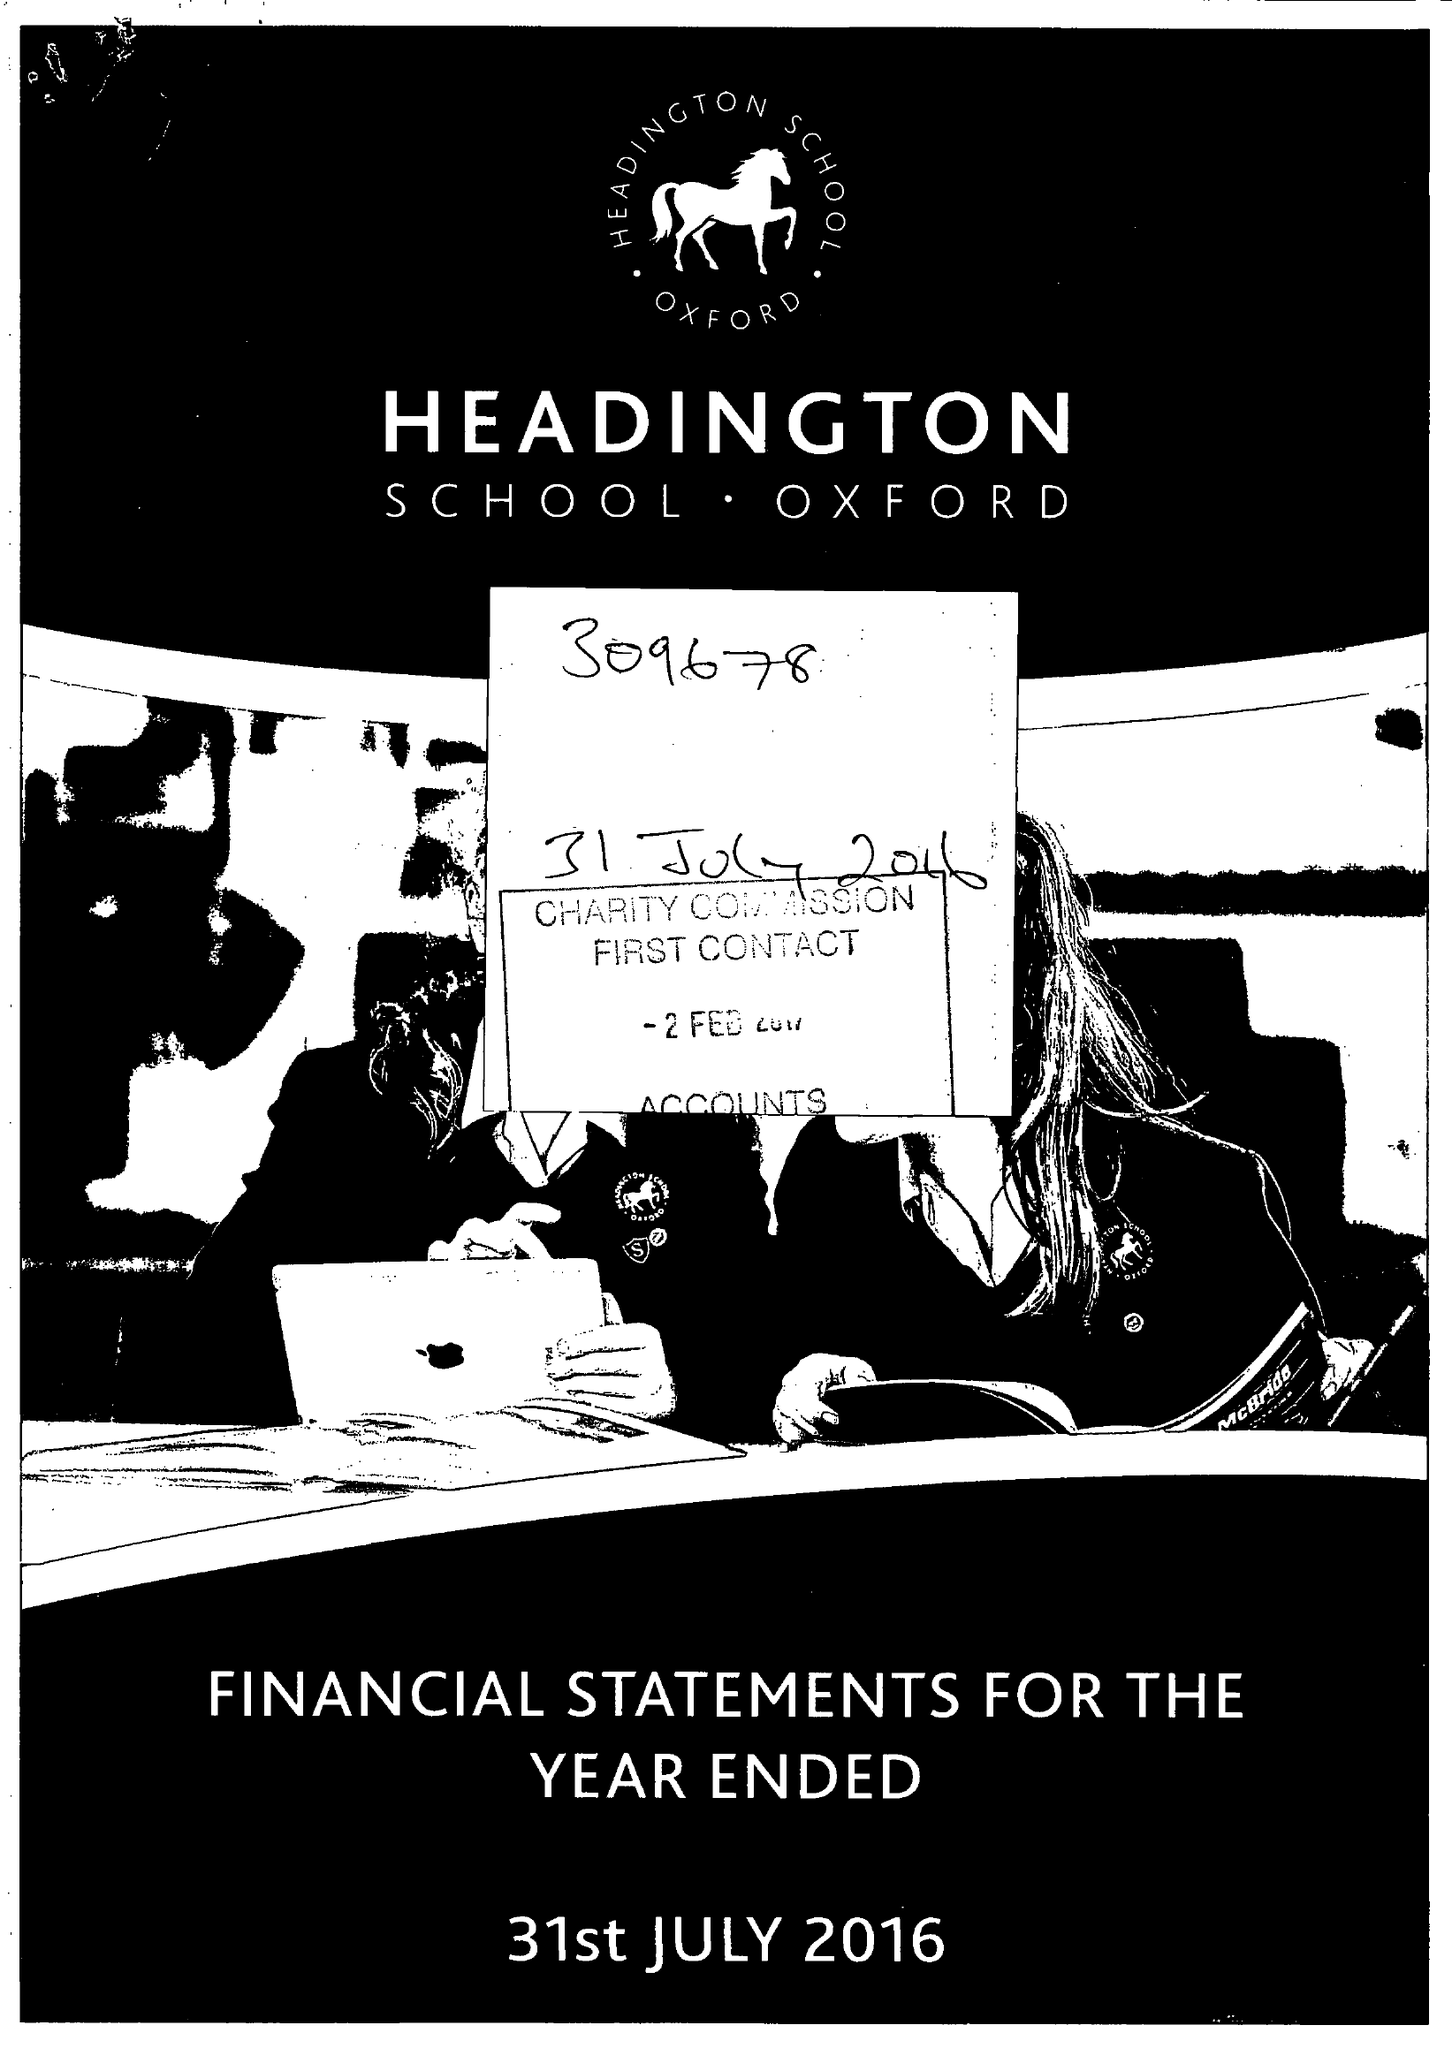What is the value for the address__postcode?
Answer the question using a single word or phrase. OX3 0BL 